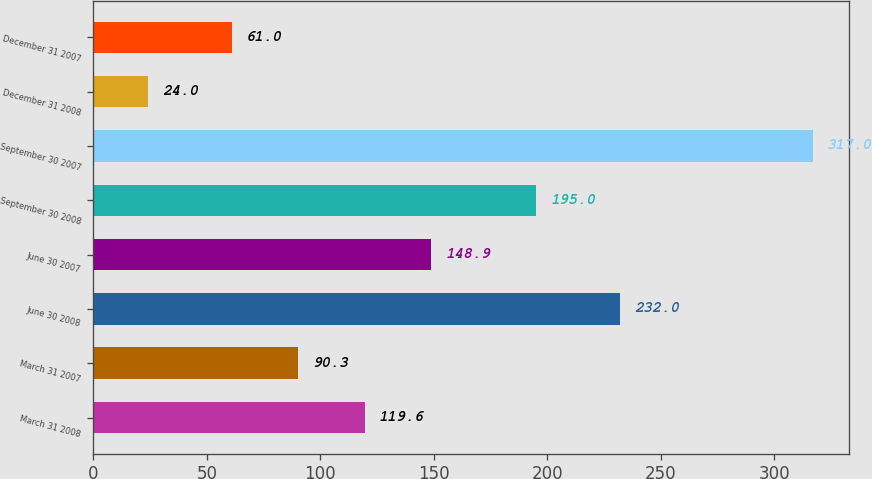Convert chart to OTSL. <chart><loc_0><loc_0><loc_500><loc_500><bar_chart><fcel>March 31 2008<fcel>March 31 2007<fcel>June 30 2008<fcel>June 30 2007<fcel>September 30 2008<fcel>September 30 2007<fcel>December 31 2008<fcel>December 31 2007<nl><fcel>119.6<fcel>90.3<fcel>232<fcel>148.9<fcel>195<fcel>317<fcel>24<fcel>61<nl></chart> 